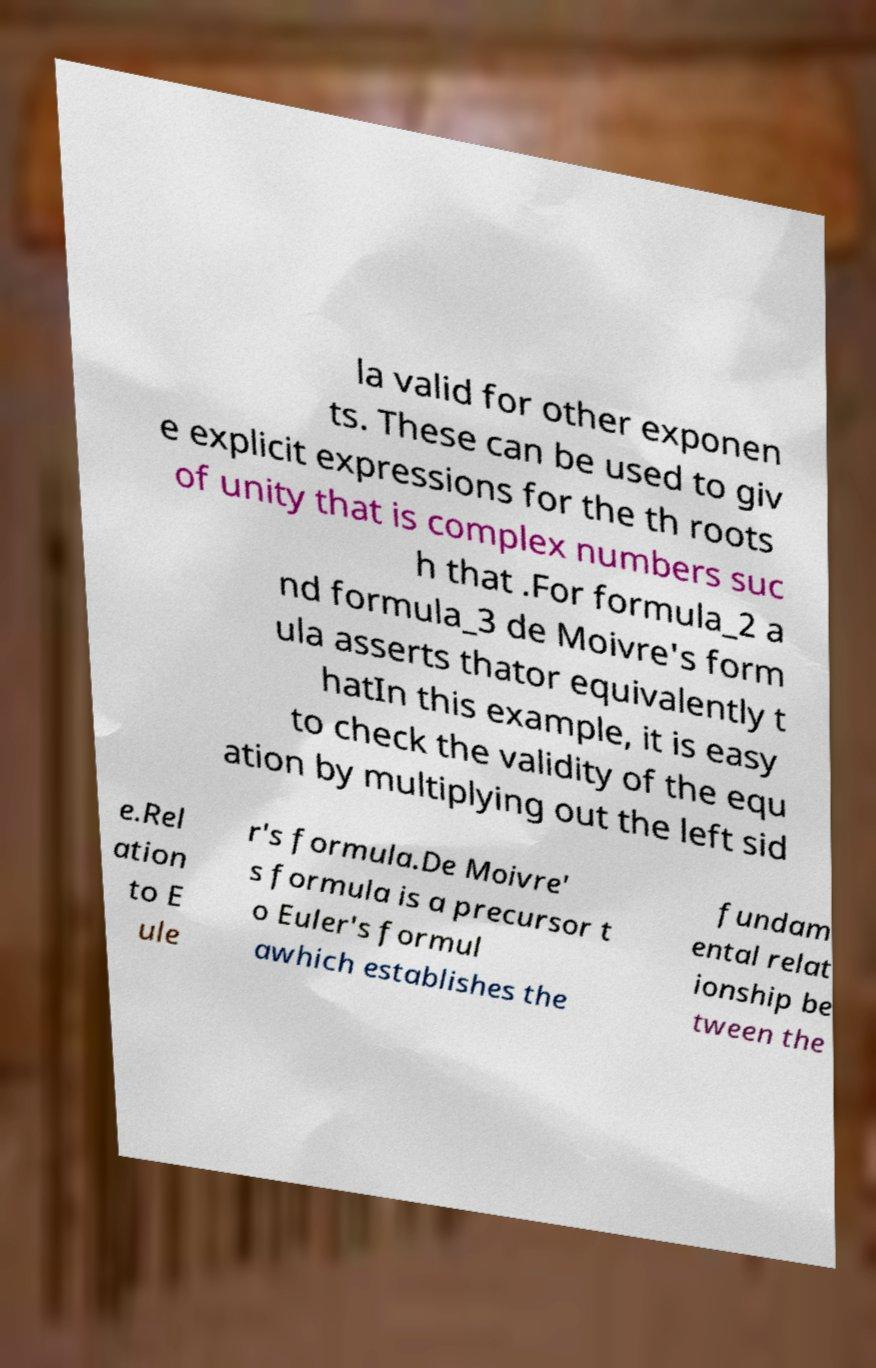Can you accurately transcribe the text from the provided image for me? la valid for other exponen ts. These can be used to giv e explicit expressions for the th roots of unity that is complex numbers suc h that .For formula_2 a nd formula_3 de Moivre's form ula asserts thator equivalently t hatIn this example, it is easy to check the validity of the equ ation by multiplying out the left sid e.Rel ation to E ule r's formula.De Moivre' s formula is a precursor t o Euler's formul awhich establishes the fundam ental relat ionship be tween the 